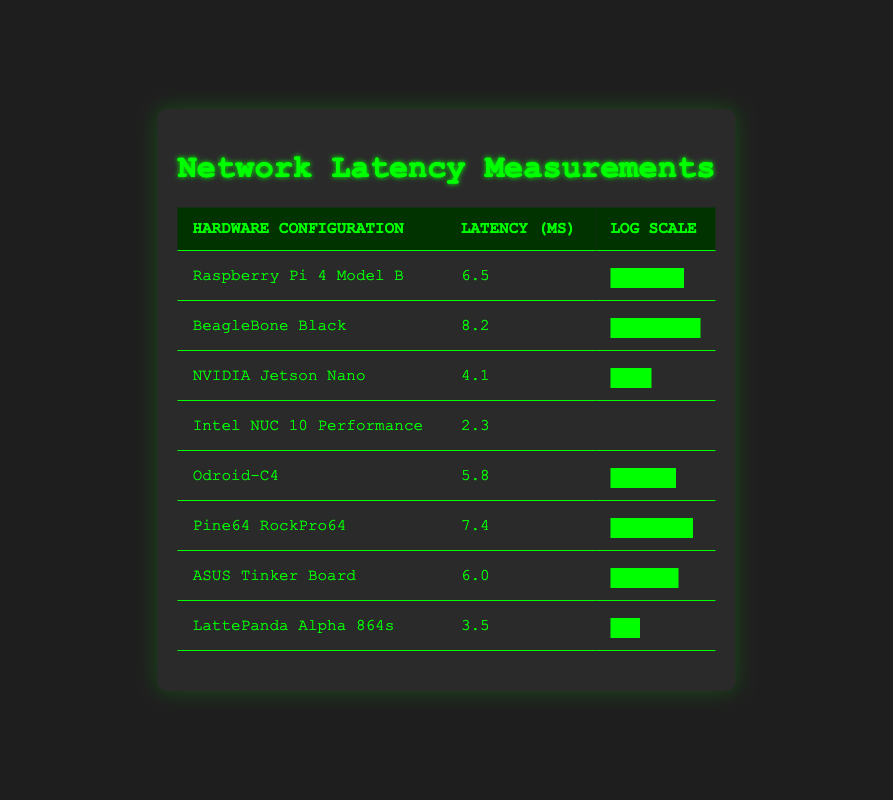What is the latency of the Intel NUC 10 Performance? The table lists the latency for each hardware configuration. For the Intel NUC 10 Performance, the latency is provided directly in the second column.
Answer: 2.3 Which hardware configuration has the highest latency? By comparing the latencies listed in the second column, the highest value can be identified. The BeagleBone Black has the highest latency of 8.2 ms.
Answer: BeagleBone Black What is the average latency across all hardware configurations? To find the average latency, we sum all the latencies: (6.5 + 8.2 + 4.1 + 2.3 + 5.8 + 7.4 + 6.0 + 3.5) = 43.8. There are 8 configurations, so the average latency is 43.8/8 = 5.475.
Answer: 5.475 Is the latency of the Raspberry Pi 4 Model B lower than that of the ASUS Tinker Board? The latency for both configurations is listed: Raspberry Pi 4 Model B has 6.5 ms, and ASUS Tinker Board has 6.0 ms. Since 6.5 is greater than 6.0, the Raspberry Pi does not have lower latency.
Answer: No What is the difference in latency between the NVIDIA Jetson Nano and the LattePanda Alpha 864s? The latency for NVIDIA Jetson Nano is 4.1 ms and for LattePanda Alpha 864s is 3.5 ms. The difference is calculated as 4.1 - 3.5 = 0.6 ms.
Answer: 0.6 Which two hardware configurations have the closest latency values? By examining the latency values closely, the Raspberry Pi 4 Model B (6.5 ms) and ASUS Tinker Board (6.0 ms) have latencies that are relatively close. The difference is only 0.5 ms.
Answer: Raspberry Pi 4 Model B and ASUS Tinker Board What percentage of the max latency (8.2 ms) is the latency of the Intel NUC 10 Performance? The latency of the Intel NUC 10 Performance is 2.3 ms. To calculate the percentage, we use the formula (latency/max latency) * 100 = (2.3/8.2) * 100 ≈ 28.05%.
Answer: Approximately 28.05% Is it true that half of the measured configurations have latency values greater than 6 ms? There are 8 configurations in total. The configurations with latency greater than 6 ms are BeagleBone Black (8.2), Pine64 RockPro64 (7.4), Raspberry Pi 4 Model B (6.5), and ASUS Tinker Board (6.0), totaling four configurations. Since this is exactly half, the statement is true.
Answer: Yes 